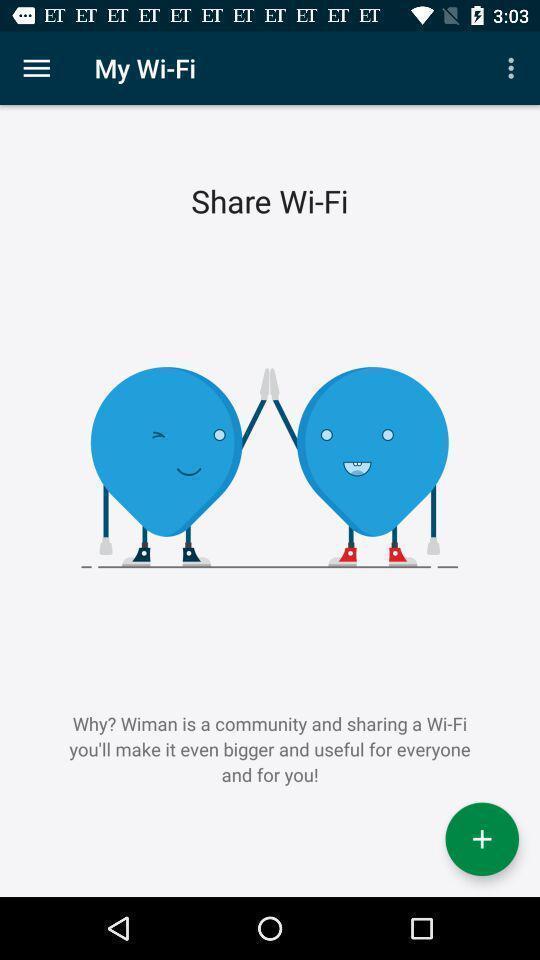What is the overall content of this screenshot? Screen shows wi-fi details. 